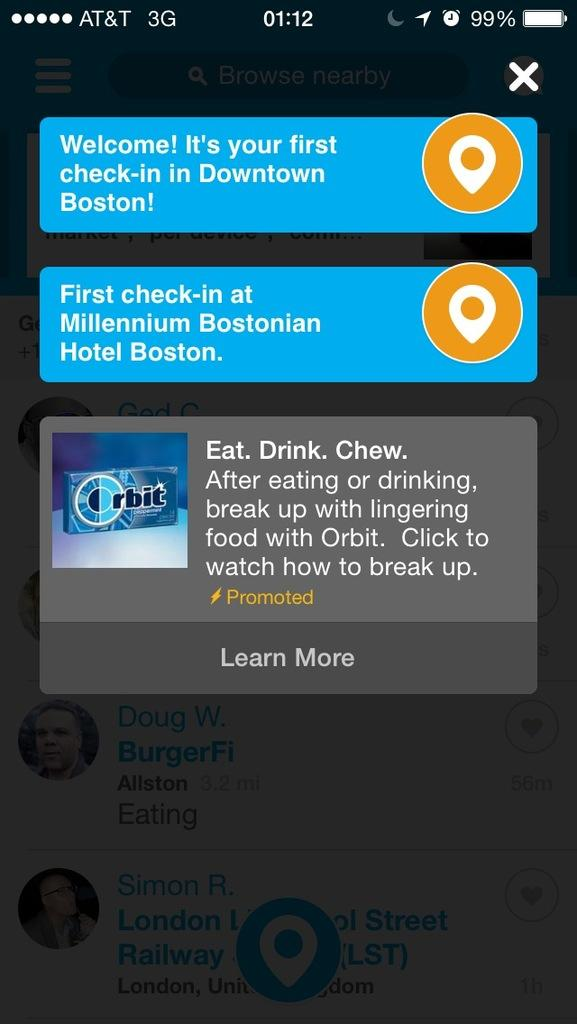What is the main object in the image? There is a mobile screen in the image. What can be seen on the mobile screen? There is text visible on the mobile screen. What type of flooring is visible in the image? There is no flooring visible in the image, as it only features a mobile screen with text. 